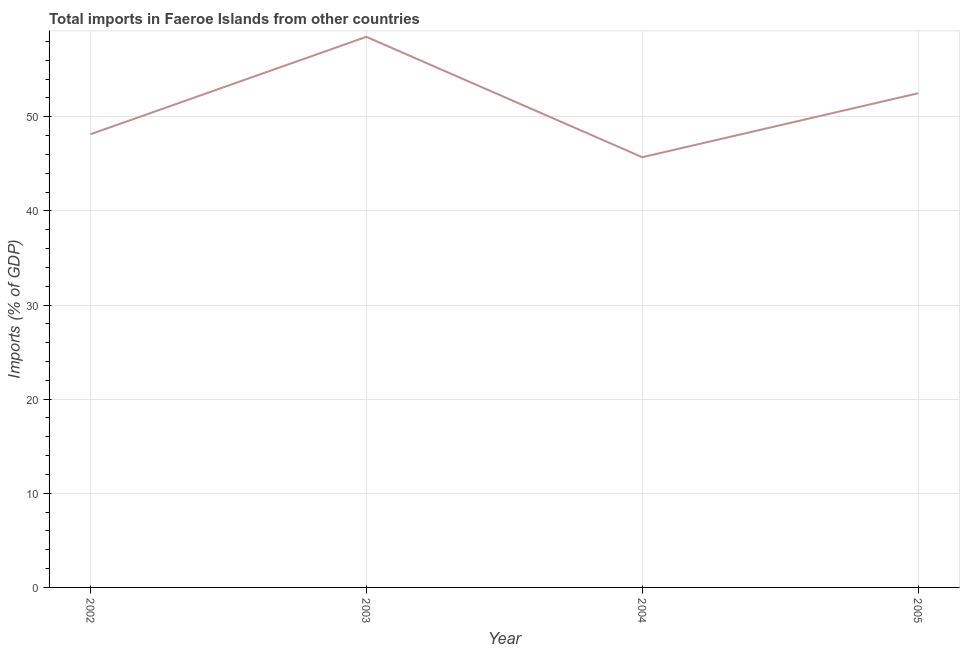What is the total imports in 2004?
Provide a short and direct response. 45.7. Across all years, what is the maximum total imports?
Offer a very short reply. 58.49. Across all years, what is the minimum total imports?
Provide a succinct answer. 45.7. In which year was the total imports minimum?
Your answer should be very brief. 2004. What is the sum of the total imports?
Offer a terse response. 204.83. What is the difference between the total imports in 2002 and 2004?
Your response must be concise. 2.44. What is the average total imports per year?
Give a very brief answer. 51.21. What is the median total imports?
Make the answer very short. 50.32. In how many years, is the total imports greater than 4 %?
Offer a very short reply. 4. What is the ratio of the total imports in 2003 to that in 2005?
Provide a short and direct response. 1.11. Is the difference between the total imports in 2003 and 2005 greater than the difference between any two years?
Your answer should be very brief. No. What is the difference between the highest and the second highest total imports?
Provide a succinct answer. 5.99. Is the sum of the total imports in 2004 and 2005 greater than the maximum total imports across all years?
Make the answer very short. Yes. What is the difference between the highest and the lowest total imports?
Offer a very short reply. 12.79. Does the total imports monotonically increase over the years?
Your response must be concise. No. How many years are there in the graph?
Provide a succinct answer. 4. Are the values on the major ticks of Y-axis written in scientific E-notation?
Keep it short and to the point. No. What is the title of the graph?
Give a very brief answer. Total imports in Faeroe Islands from other countries. What is the label or title of the X-axis?
Keep it short and to the point. Year. What is the label or title of the Y-axis?
Provide a succinct answer. Imports (% of GDP). What is the Imports (% of GDP) in 2002?
Your answer should be compact. 48.14. What is the Imports (% of GDP) of 2003?
Ensure brevity in your answer.  58.49. What is the Imports (% of GDP) in 2004?
Offer a terse response. 45.7. What is the Imports (% of GDP) of 2005?
Ensure brevity in your answer.  52.5. What is the difference between the Imports (% of GDP) in 2002 and 2003?
Your answer should be very brief. -10.35. What is the difference between the Imports (% of GDP) in 2002 and 2004?
Provide a succinct answer. 2.44. What is the difference between the Imports (% of GDP) in 2002 and 2005?
Provide a short and direct response. -4.35. What is the difference between the Imports (% of GDP) in 2003 and 2004?
Your answer should be very brief. 12.79. What is the difference between the Imports (% of GDP) in 2003 and 2005?
Provide a short and direct response. 5.99. What is the difference between the Imports (% of GDP) in 2004 and 2005?
Offer a terse response. -6.79. What is the ratio of the Imports (% of GDP) in 2002 to that in 2003?
Your response must be concise. 0.82. What is the ratio of the Imports (% of GDP) in 2002 to that in 2004?
Your answer should be compact. 1.05. What is the ratio of the Imports (% of GDP) in 2002 to that in 2005?
Provide a succinct answer. 0.92. What is the ratio of the Imports (% of GDP) in 2003 to that in 2004?
Offer a terse response. 1.28. What is the ratio of the Imports (% of GDP) in 2003 to that in 2005?
Give a very brief answer. 1.11. What is the ratio of the Imports (% of GDP) in 2004 to that in 2005?
Offer a terse response. 0.87. 